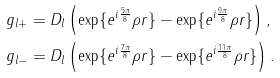Convert formula to latex. <formula><loc_0><loc_0><loc_500><loc_500>g _ { l + } & = D _ { l } \left ( \exp \{ e ^ { i \frac { 5 \pi } { 8 } } \rho r \} - \exp \{ e ^ { i \frac { 9 \pi } { 8 } } \rho r \} \right ) , \\ g _ { l - } & = D _ { l } \left ( \exp \{ e ^ { i \frac { 7 \pi } { 8 } } \rho r \} - \exp \{ e ^ { i \frac { 1 1 \pi } { 8 } } \rho r \} \right ) .</formula> 